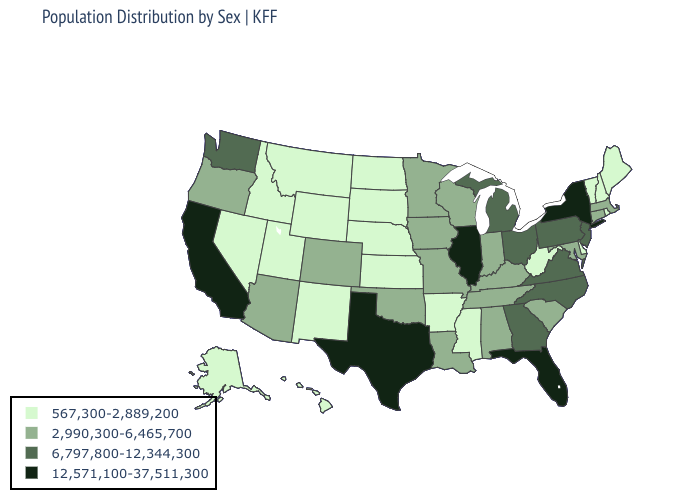Name the states that have a value in the range 6,797,800-12,344,300?
Answer briefly. Georgia, Michigan, New Jersey, North Carolina, Ohio, Pennsylvania, Virginia, Washington. Name the states that have a value in the range 6,797,800-12,344,300?
Be succinct. Georgia, Michigan, New Jersey, North Carolina, Ohio, Pennsylvania, Virginia, Washington. Does the first symbol in the legend represent the smallest category?
Write a very short answer. Yes. Does the map have missing data?
Give a very brief answer. No. What is the lowest value in the USA?
Short answer required. 567,300-2,889,200. What is the value of Tennessee?
Answer briefly. 2,990,300-6,465,700. What is the lowest value in states that border Missouri?
Give a very brief answer. 567,300-2,889,200. Does Oregon have the lowest value in the USA?
Answer briefly. No. What is the value of Texas?
Be succinct. 12,571,100-37,511,300. What is the lowest value in the South?
Concise answer only. 567,300-2,889,200. Does North Dakota have a higher value than Rhode Island?
Write a very short answer. No. Which states hav the highest value in the Northeast?
Be succinct. New York. What is the highest value in the USA?
Short answer required. 12,571,100-37,511,300. What is the lowest value in states that border Alabama?
Answer briefly. 567,300-2,889,200. Does Colorado have the lowest value in the USA?
Be succinct. No. 